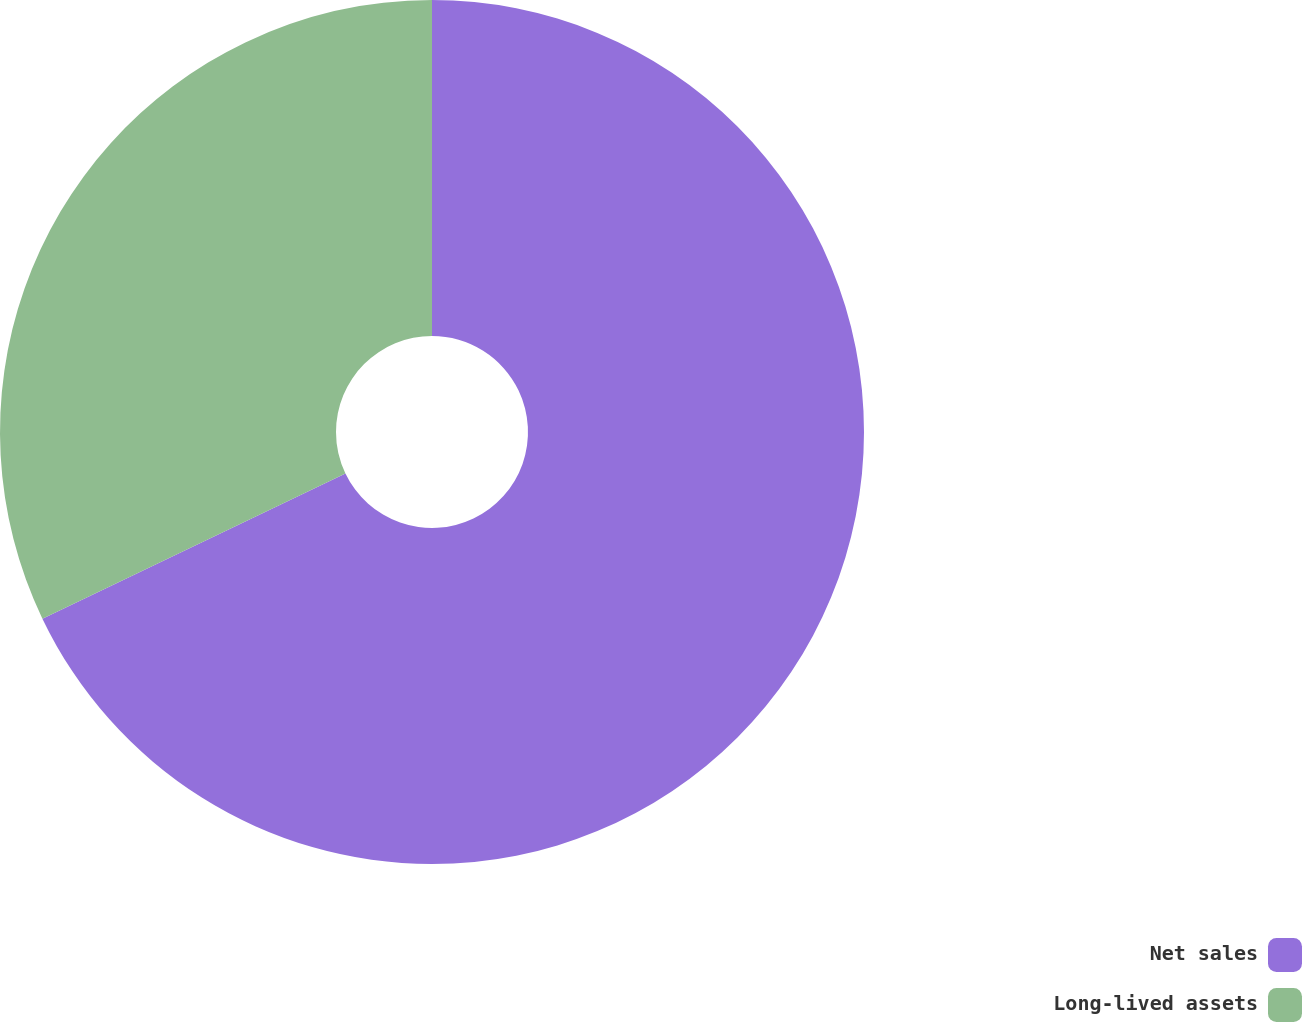<chart> <loc_0><loc_0><loc_500><loc_500><pie_chart><fcel>Net sales<fcel>Long-lived assets<nl><fcel>67.89%<fcel>32.11%<nl></chart> 